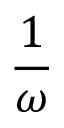Convert formula to latex. <formula><loc_0><loc_0><loc_500><loc_500>\frac { 1 } { \omega }</formula> 